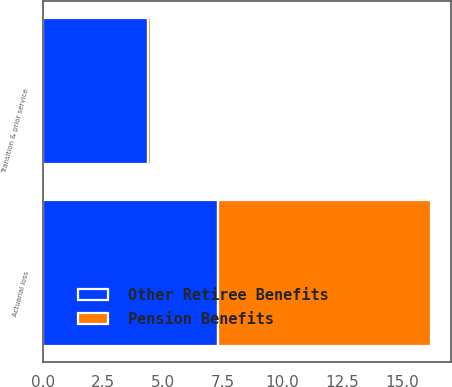<chart> <loc_0><loc_0><loc_500><loc_500><stacked_bar_chart><ecel><fcel>Actuarial loss<fcel>Transition & prior service<nl><fcel>Other Retiree Benefits<fcel>7.3<fcel>4.4<nl><fcel>Pension Benefits<fcel>8.9<fcel>0.1<nl></chart> 